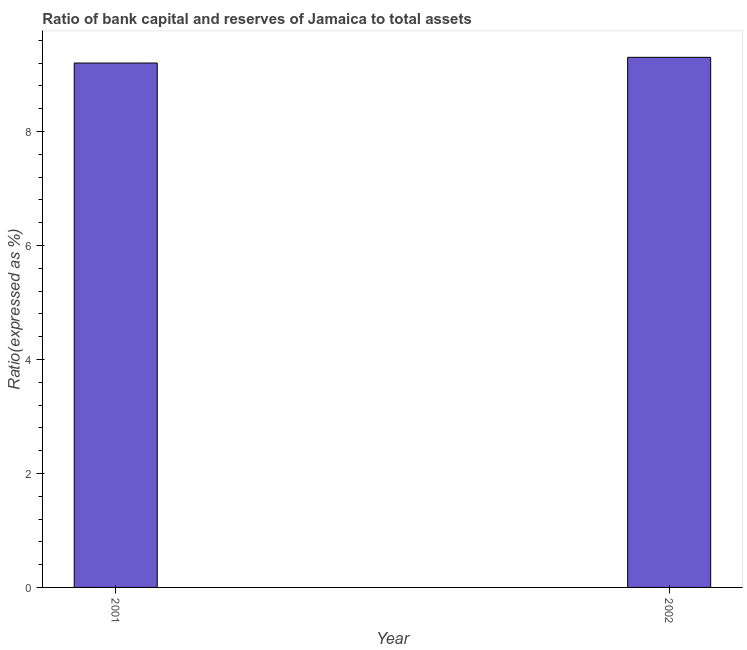What is the title of the graph?
Your answer should be compact. Ratio of bank capital and reserves of Jamaica to total assets. What is the label or title of the Y-axis?
Offer a terse response. Ratio(expressed as %). Across all years, what is the maximum bank capital to assets ratio?
Your response must be concise. 9.3. In which year was the bank capital to assets ratio maximum?
Offer a terse response. 2002. What is the difference between the bank capital to assets ratio in 2001 and 2002?
Keep it short and to the point. -0.1. What is the average bank capital to assets ratio per year?
Offer a very short reply. 9.25. What is the median bank capital to assets ratio?
Offer a very short reply. 9.25. In how many years, is the bank capital to assets ratio greater than 8.8 %?
Your answer should be compact. 2. Is the bank capital to assets ratio in 2001 less than that in 2002?
Keep it short and to the point. Yes. In how many years, is the bank capital to assets ratio greater than the average bank capital to assets ratio taken over all years?
Provide a short and direct response. 1. How many bars are there?
Provide a short and direct response. 2. How many years are there in the graph?
Your answer should be compact. 2. What is the Ratio(expressed as %) in 2001?
Your answer should be compact. 9.2. What is the difference between the Ratio(expressed as %) in 2001 and 2002?
Keep it short and to the point. -0.1. What is the ratio of the Ratio(expressed as %) in 2001 to that in 2002?
Ensure brevity in your answer.  0.99. 